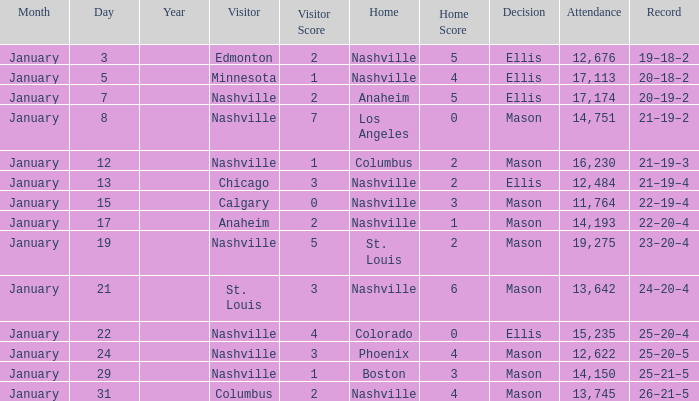On January 29, who had the decision of Mason? Nashville. Can you parse all the data within this table? {'header': ['Month', 'Day', 'Year', 'Visitor', 'Visitor Score', 'Home', 'Home Score', 'Decision', 'Attendance', 'Record'], 'rows': [['January', '3', '', 'Edmonton', '2', 'Nashville', '5', 'Ellis', '12,676', '19–18–2'], ['January', '5', '', 'Minnesota', '1', 'Nashville', '4', 'Ellis', '17,113', '20–18–2'], ['January', '7', '', 'Nashville', '2', 'Anaheim', '5', 'Ellis', '17,174', '20–19–2'], ['January', '8', '', 'Nashville', '7', 'Los Angeles', '0', 'Mason', '14,751', '21–19–2'], ['January', '12', '', 'Nashville', '1', 'Columbus', '2', 'Mason', '16,230', '21–19–3'], ['January', '13', '', 'Chicago', '3', 'Nashville', '2', 'Ellis', '12,484', '21–19–4'], ['January', '15', '', 'Calgary', '0', 'Nashville', '3', 'Mason', '11,764', '22–19–4'], ['January', '17', '', 'Anaheim', '2', 'Nashville', '1', 'Mason', '14,193', '22–20–4'], ['January', '19', '', 'Nashville', '5', 'St. Louis', '2', 'Mason', '19,275', '23–20–4'], ['January', '21', '', 'St. Louis', '3', 'Nashville', '6', 'Mason', '13,642', '24–20–4'], ['January', '22', '', 'Nashville', '4', 'Colorado', '0', 'Ellis', '15,235', '25–20–4'], ['January', '24', '', 'Nashville', '3', 'Phoenix', '4', 'Mason', '12,622', '25–20–5'], ['January', '29', '', 'Nashville', '1', 'Boston', '3', 'Mason', '14,150', '25–21–5'], ['January', '31', '', 'Columbus', '2', 'Nashville', '4', 'Mason', '13,745', '26–21–5']]} 